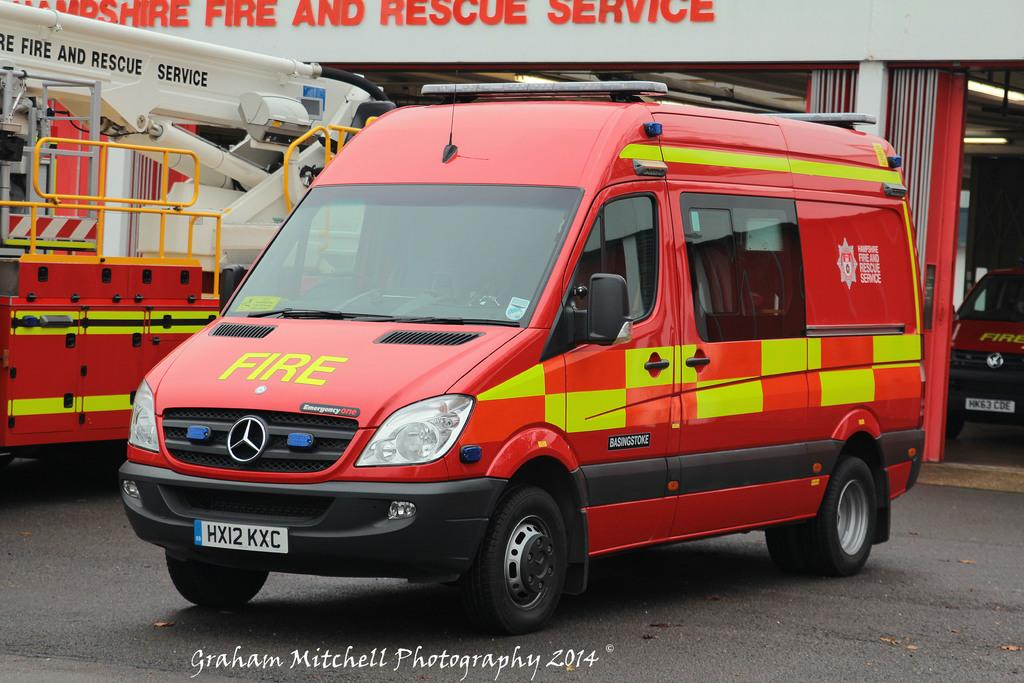<image>
Write a terse but informative summary of the picture. a red van with the words FIRE on the hood 